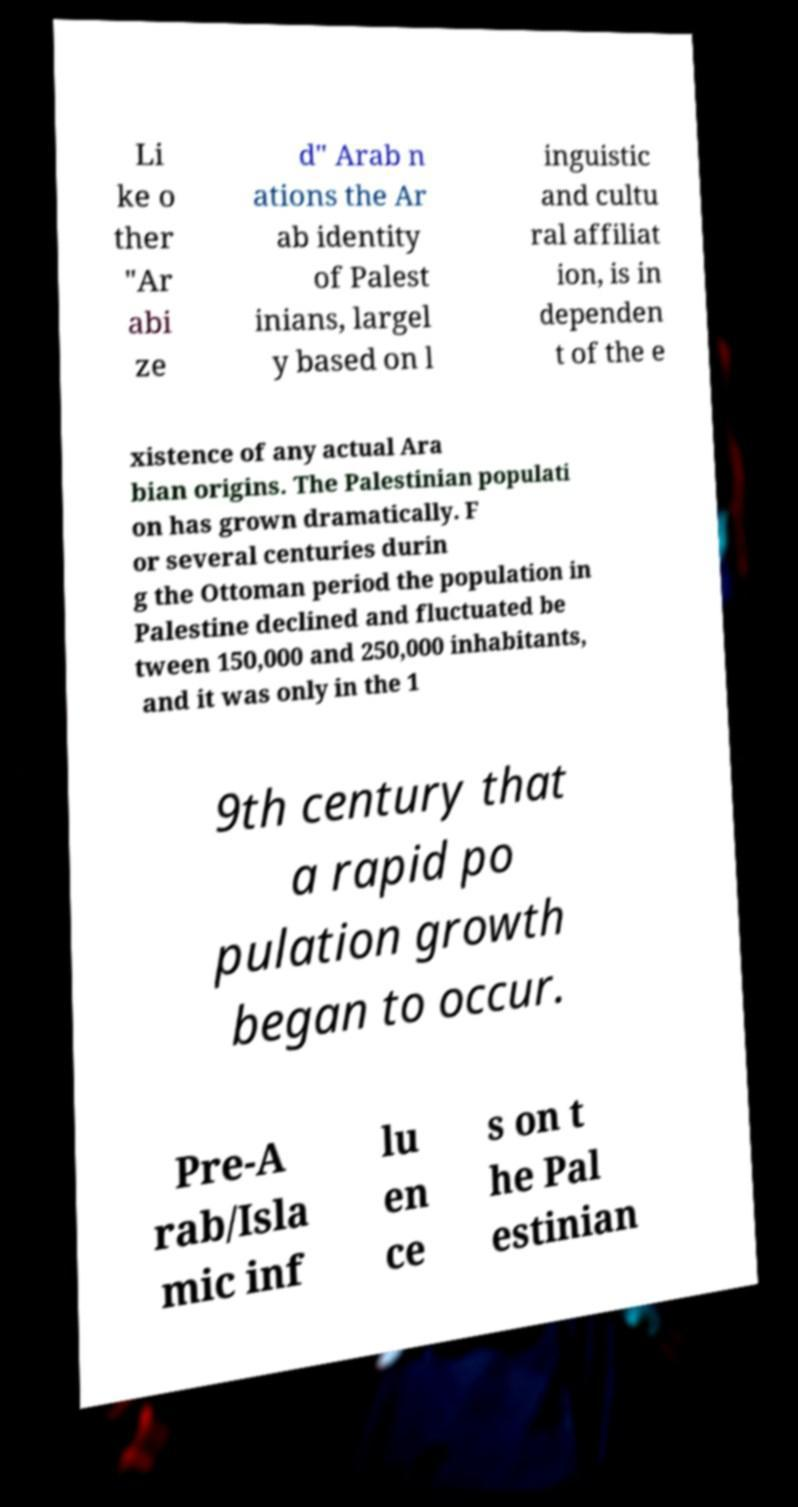Can you read and provide the text displayed in the image?This photo seems to have some interesting text. Can you extract and type it out for me? Li ke o ther "Ar abi ze d" Arab n ations the Ar ab identity of Palest inians, largel y based on l inguistic and cultu ral affiliat ion, is in dependen t of the e xistence of any actual Ara bian origins. The Palestinian populati on has grown dramatically. F or several centuries durin g the Ottoman period the population in Palestine declined and fluctuated be tween 150,000 and 250,000 inhabitants, and it was only in the 1 9th century that a rapid po pulation growth began to occur. Pre-A rab/Isla mic inf lu en ce s on t he Pal estinian 